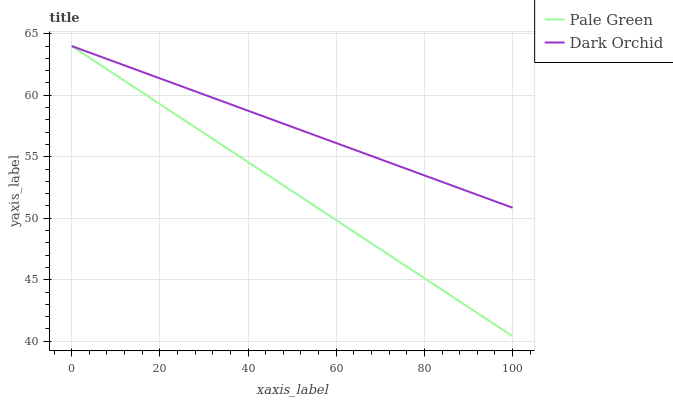Does Pale Green have the minimum area under the curve?
Answer yes or no. Yes. Does Dark Orchid have the maximum area under the curve?
Answer yes or no. Yes. Does Dark Orchid have the minimum area under the curve?
Answer yes or no. No. Is Pale Green the smoothest?
Answer yes or no. Yes. Is Dark Orchid the roughest?
Answer yes or no. Yes. Is Dark Orchid the smoothest?
Answer yes or no. No. Does Dark Orchid have the lowest value?
Answer yes or no. No. Does Dark Orchid have the highest value?
Answer yes or no. Yes. 